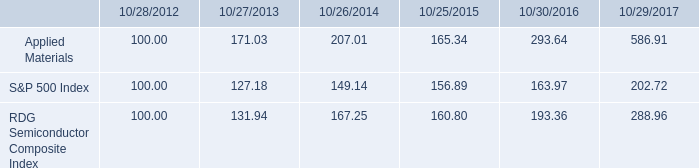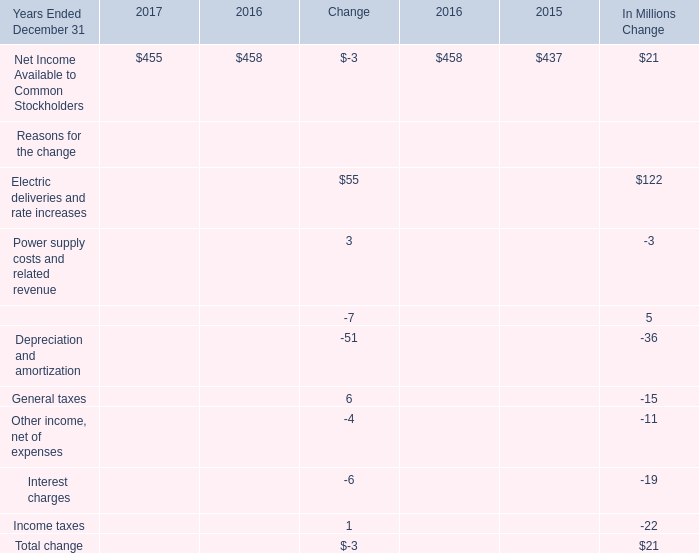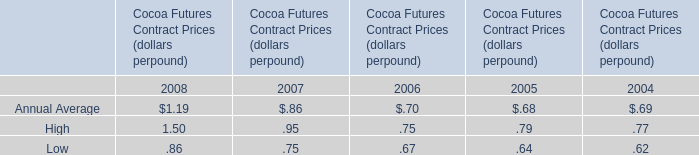what is the roi in s&p500 if the investment was made in 2012 and sold in 2015? 
Computations: ((156.89 - 100) / 100)
Answer: 0.5689. 